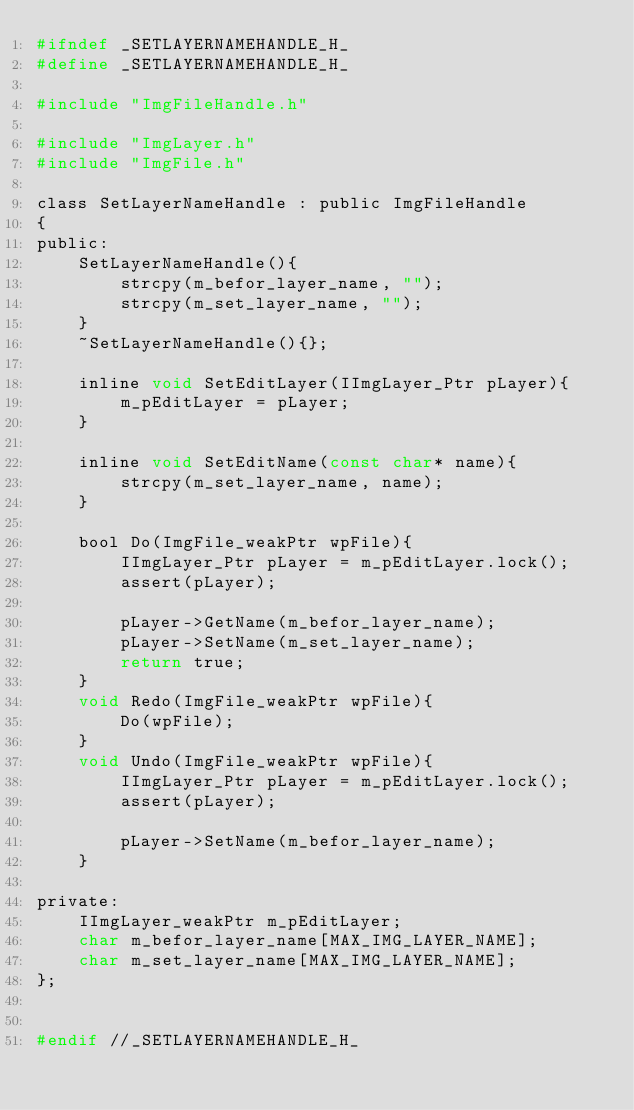Convert code to text. <code><loc_0><loc_0><loc_500><loc_500><_C_>#ifndef _SETLAYERNAMEHANDLE_H_
#define _SETLAYERNAMEHANDLE_H_

#include "ImgFileHandle.h"

#include "ImgLayer.h"
#include "ImgFile.h"

class SetLayerNameHandle : public ImgFileHandle
{
public:
	SetLayerNameHandle(){
		strcpy(m_befor_layer_name, "");
		strcpy(m_set_layer_name, "");
	}
	~SetLayerNameHandle(){};

	inline void SetEditLayer(IImgLayer_Ptr pLayer){
		m_pEditLayer = pLayer;
	}

	inline void SetEditName(const char* name){
		strcpy(m_set_layer_name, name);
	}

	bool Do(ImgFile_weakPtr wpFile){
		IImgLayer_Ptr pLayer = m_pEditLayer.lock();
		assert(pLayer);

		pLayer->GetName(m_befor_layer_name);
		pLayer->SetName(m_set_layer_name);
		return true;
	}
	void Redo(ImgFile_weakPtr wpFile){
		Do(wpFile);
	}
	void Undo(ImgFile_weakPtr wpFile){
		IImgLayer_Ptr pLayer = m_pEditLayer.lock();
		assert(pLayer);

		pLayer->SetName(m_befor_layer_name);
	}

private:
	IImgLayer_weakPtr m_pEditLayer;
	char m_befor_layer_name[MAX_IMG_LAYER_NAME];
	char m_set_layer_name[MAX_IMG_LAYER_NAME];
};


#endif //_SETLAYERNAMEHANDLE_H_</code> 